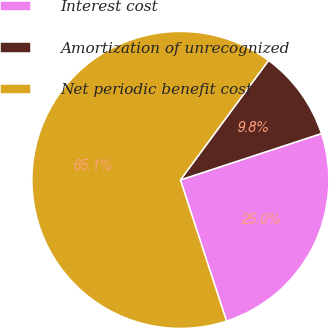<chart> <loc_0><loc_0><loc_500><loc_500><pie_chart><fcel>Interest cost<fcel>Amortization of unrecognized<fcel>Net periodic benefit cost<nl><fcel>25.03%<fcel>9.83%<fcel>65.14%<nl></chart> 